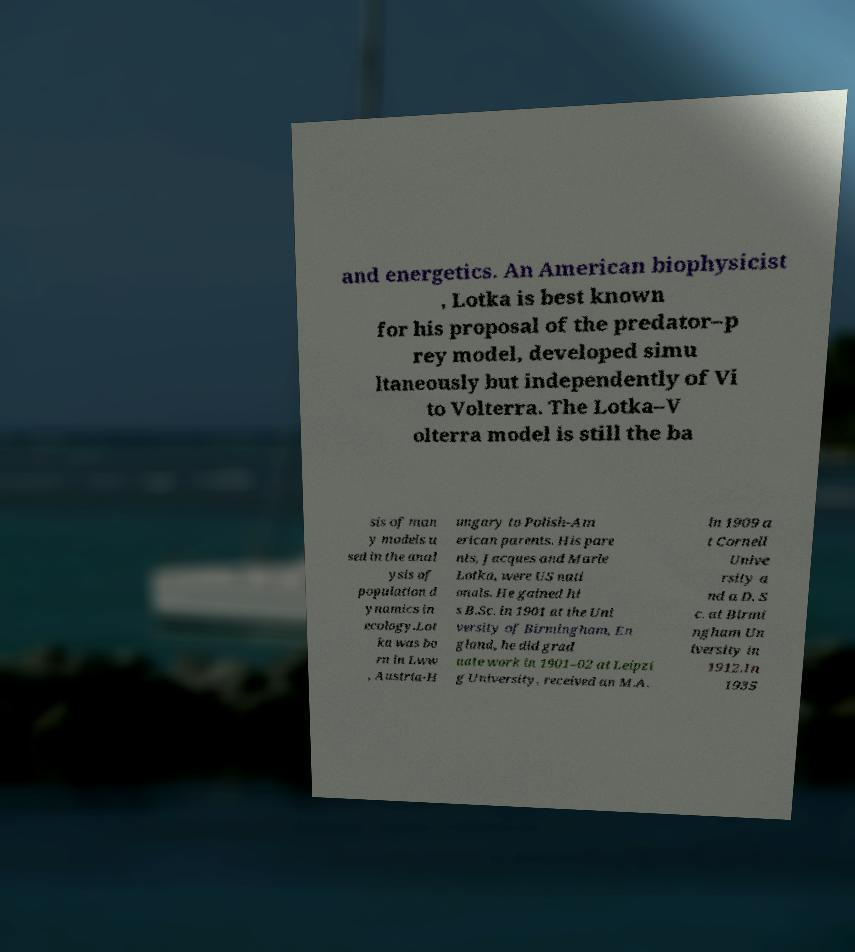Could you extract and type out the text from this image? and energetics. An American biophysicist , Lotka is best known for his proposal of the predator–p rey model, developed simu ltaneously but independently of Vi to Volterra. The Lotka–V olterra model is still the ba sis of man y models u sed in the anal ysis of population d ynamics in ecology.Lot ka was bo rn in Lww , Austria-H ungary to Polish-Am erican parents. His pare nts, Jacques and Marie Lotka, were US nati onals. He gained hi s B.Sc. in 1901 at the Uni versity of Birmingham, En gland, he did grad uate work in 1901–02 at Leipzi g University, received an M.A. in 1909 a t Cornell Unive rsity a nd a D. S c. at Birmi ngham Un iversity in 1912.In 1935 